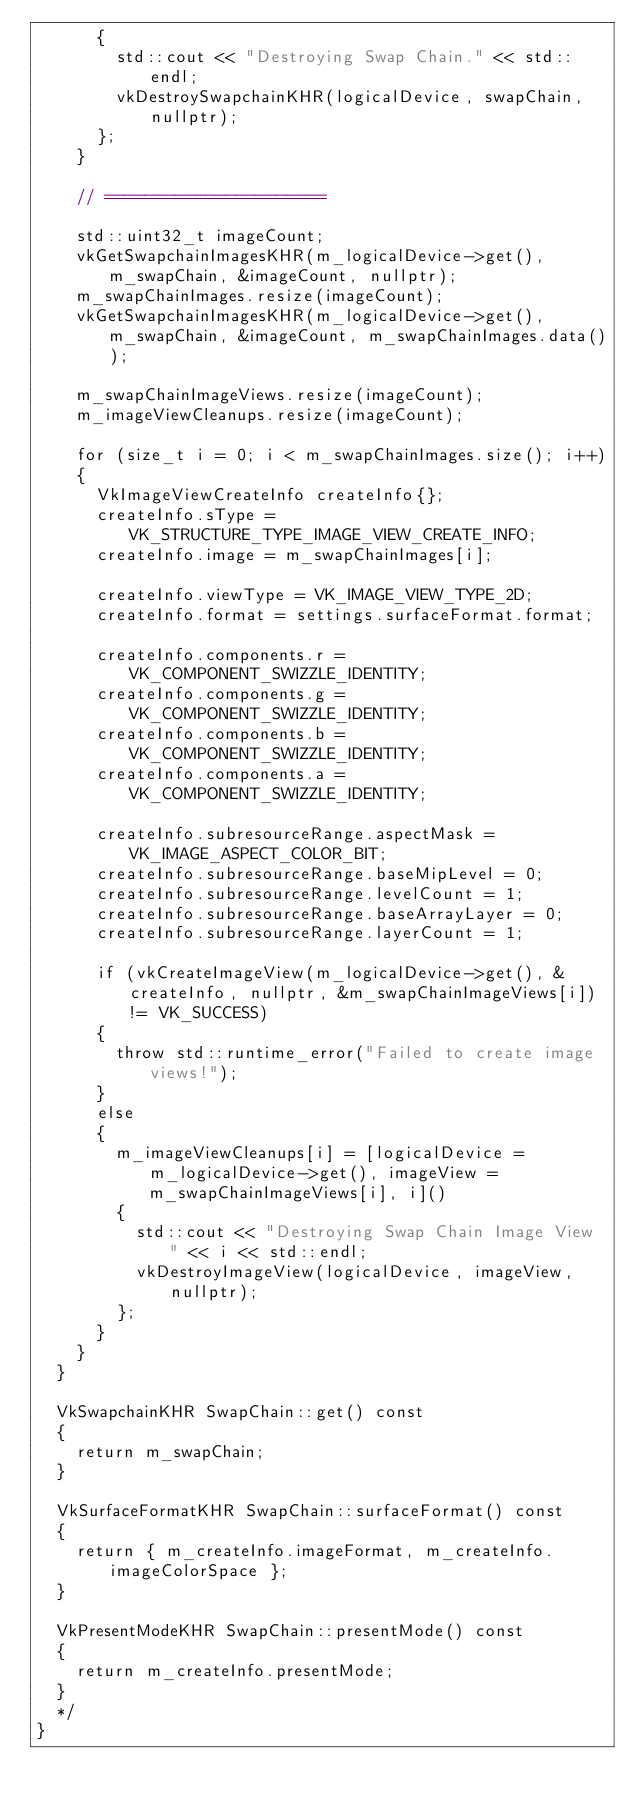<code> <loc_0><loc_0><loc_500><loc_500><_C++_>			{
				std::cout << "Destroying Swap Chain." << std::endl;
				vkDestroySwapchainKHR(logicalDevice, swapChain, nullptr);
			};
		}

		// ======================

		std::uint32_t imageCount;
		vkGetSwapchainImagesKHR(m_logicalDevice->get(), m_swapChain, &imageCount, nullptr);
		m_swapChainImages.resize(imageCount);
		vkGetSwapchainImagesKHR(m_logicalDevice->get(), m_swapChain, &imageCount, m_swapChainImages.data());

		m_swapChainImageViews.resize(imageCount);
		m_imageViewCleanups.resize(imageCount);

		for (size_t i = 0; i < m_swapChainImages.size(); i++)
		{
			VkImageViewCreateInfo createInfo{};
			createInfo.sType = VK_STRUCTURE_TYPE_IMAGE_VIEW_CREATE_INFO;
			createInfo.image = m_swapChainImages[i];

			createInfo.viewType = VK_IMAGE_VIEW_TYPE_2D;
			createInfo.format = settings.surfaceFormat.format;

			createInfo.components.r = VK_COMPONENT_SWIZZLE_IDENTITY;
			createInfo.components.g = VK_COMPONENT_SWIZZLE_IDENTITY;
			createInfo.components.b = VK_COMPONENT_SWIZZLE_IDENTITY;
			createInfo.components.a = VK_COMPONENT_SWIZZLE_IDENTITY;

			createInfo.subresourceRange.aspectMask = VK_IMAGE_ASPECT_COLOR_BIT;
			createInfo.subresourceRange.baseMipLevel = 0;
			createInfo.subresourceRange.levelCount = 1;
			createInfo.subresourceRange.baseArrayLayer = 0;
			createInfo.subresourceRange.layerCount = 1;

			if (vkCreateImageView(m_logicalDevice->get(), &createInfo, nullptr, &m_swapChainImageViews[i]) != VK_SUCCESS)
			{
				throw std::runtime_error("Failed to create image views!");
			}
			else
			{
				m_imageViewCleanups[i] = [logicalDevice = m_logicalDevice->get(), imageView = m_swapChainImageViews[i], i]()
				{
					std::cout << "Destroying Swap Chain Image View " << i << std::endl;
					vkDestroyImageView(logicalDevice, imageView, nullptr);
				};
			}
		}
	}

	VkSwapchainKHR SwapChain::get() const
	{
		return m_swapChain;
	}

	VkSurfaceFormatKHR SwapChain::surfaceFormat() const
	{
		return { m_createInfo.imageFormat, m_createInfo.imageColorSpace };
	}

	VkPresentModeKHR SwapChain::presentMode() const
	{
		return m_createInfo.presentMode;
	}
	*/
}
</code> 